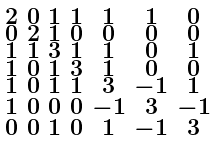Convert formula to latex. <formula><loc_0><loc_0><loc_500><loc_500>\begin{smallmatrix} 2 & 0 & 1 & 1 & 1 & 1 & 0 \\ 0 & 2 & 1 & 0 & 0 & 0 & 0 \\ 1 & 1 & 3 & 1 & 1 & 0 & 1 \\ 1 & 0 & 1 & 3 & 1 & 0 & 0 \\ 1 & 0 & 1 & 1 & 3 & - 1 & 1 \\ 1 & 0 & 0 & 0 & - 1 & 3 & - 1 \\ 0 & 0 & 1 & 0 & 1 & - 1 & 3 \end{smallmatrix}</formula> 